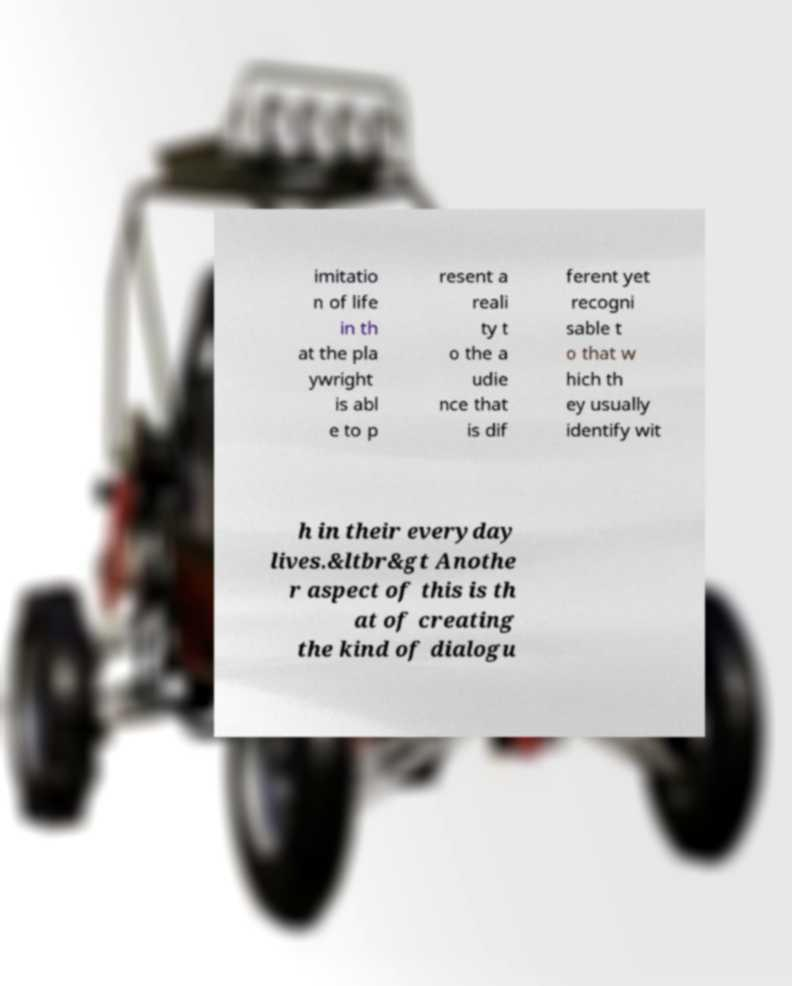There's text embedded in this image that I need extracted. Can you transcribe it verbatim? imitatio n of life in th at the pla ywright is abl e to p resent a reali ty t o the a udie nce that is dif ferent yet recogni sable t o that w hich th ey usually identify wit h in their everyday lives.&ltbr&gt Anothe r aspect of this is th at of creating the kind of dialogu 